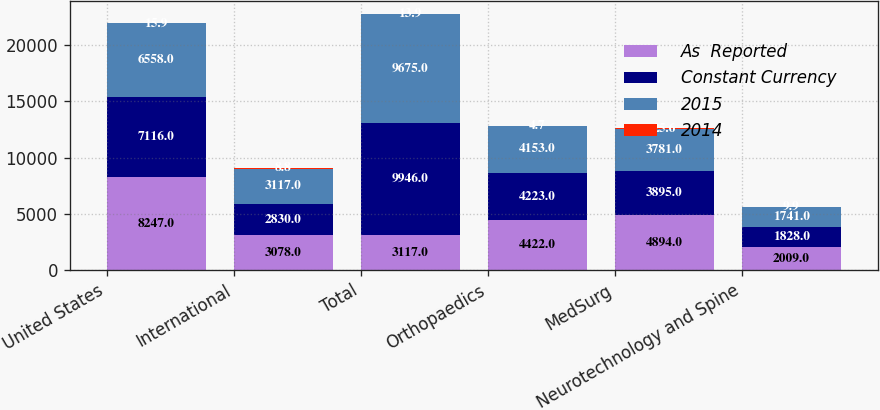<chart> <loc_0><loc_0><loc_500><loc_500><stacked_bar_chart><ecel><fcel>United States<fcel>International<fcel>Total<fcel>Orthopaedics<fcel>MedSurg<fcel>Neurotechnology and Spine<nl><fcel>As  Reported<fcel>8247<fcel>3078<fcel>3117<fcel>4422<fcel>4894<fcel>2009<nl><fcel>Constant Currency<fcel>7116<fcel>2830<fcel>9946<fcel>4223<fcel>3895<fcel>1828<nl><fcel>2015<fcel>6558<fcel>3117<fcel>9675<fcel>4153<fcel>3781<fcel>1741<nl><fcel>2014<fcel>15.9<fcel>8.8<fcel>13.9<fcel>4.7<fcel>25.6<fcel>9.9<nl></chart> 